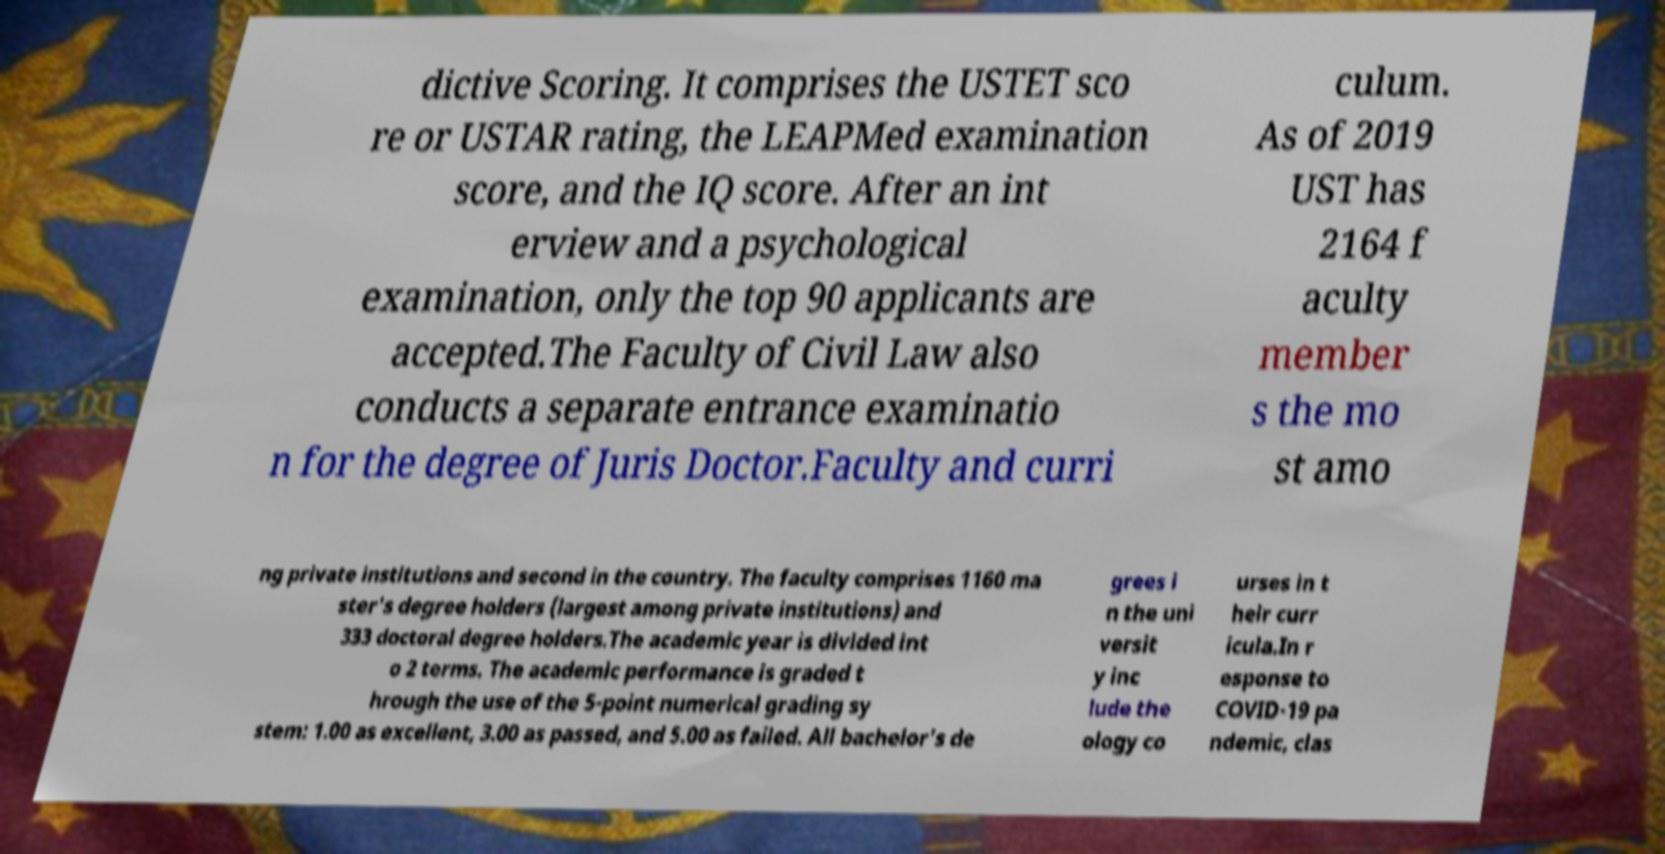What messages or text are displayed in this image? I need them in a readable, typed format. dictive Scoring. It comprises the USTET sco re or USTAR rating, the LEAPMed examination score, and the IQ score. After an int erview and a psychological examination, only the top 90 applicants are accepted.The Faculty of Civil Law also conducts a separate entrance examinatio n for the degree of Juris Doctor.Faculty and curri culum. As of 2019 UST has 2164 f aculty member s the mo st amo ng private institutions and second in the country. The faculty comprises 1160 ma ster's degree holders (largest among private institutions) and 333 doctoral degree holders.The academic year is divided int o 2 terms. The academic performance is graded t hrough the use of the 5-point numerical grading sy stem: 1.00 as excellent, 3.00 as passed, and 5.00 as failed. All bachelor's de grees i n the uni versit y inc lude the ology co urses in t heir curr icula.In r esponse to COVID-19 pa ndemic, clas 